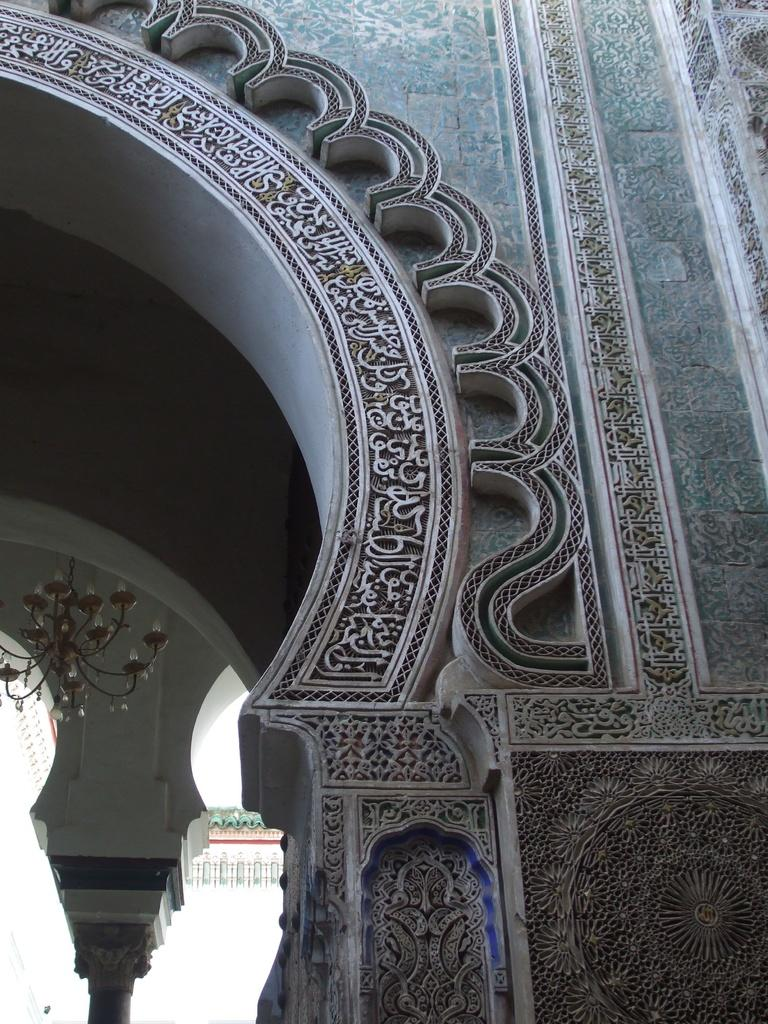What can be seen on the wall in the image? There is a wall with a design in the image. What type of lighting fixture is present in the image? There is a chandelier attached to the ceiling in the image. How does the thumb affect the design on the wall in the image? There is no thumb present in the image, so it cannot affect the design on the wall. 